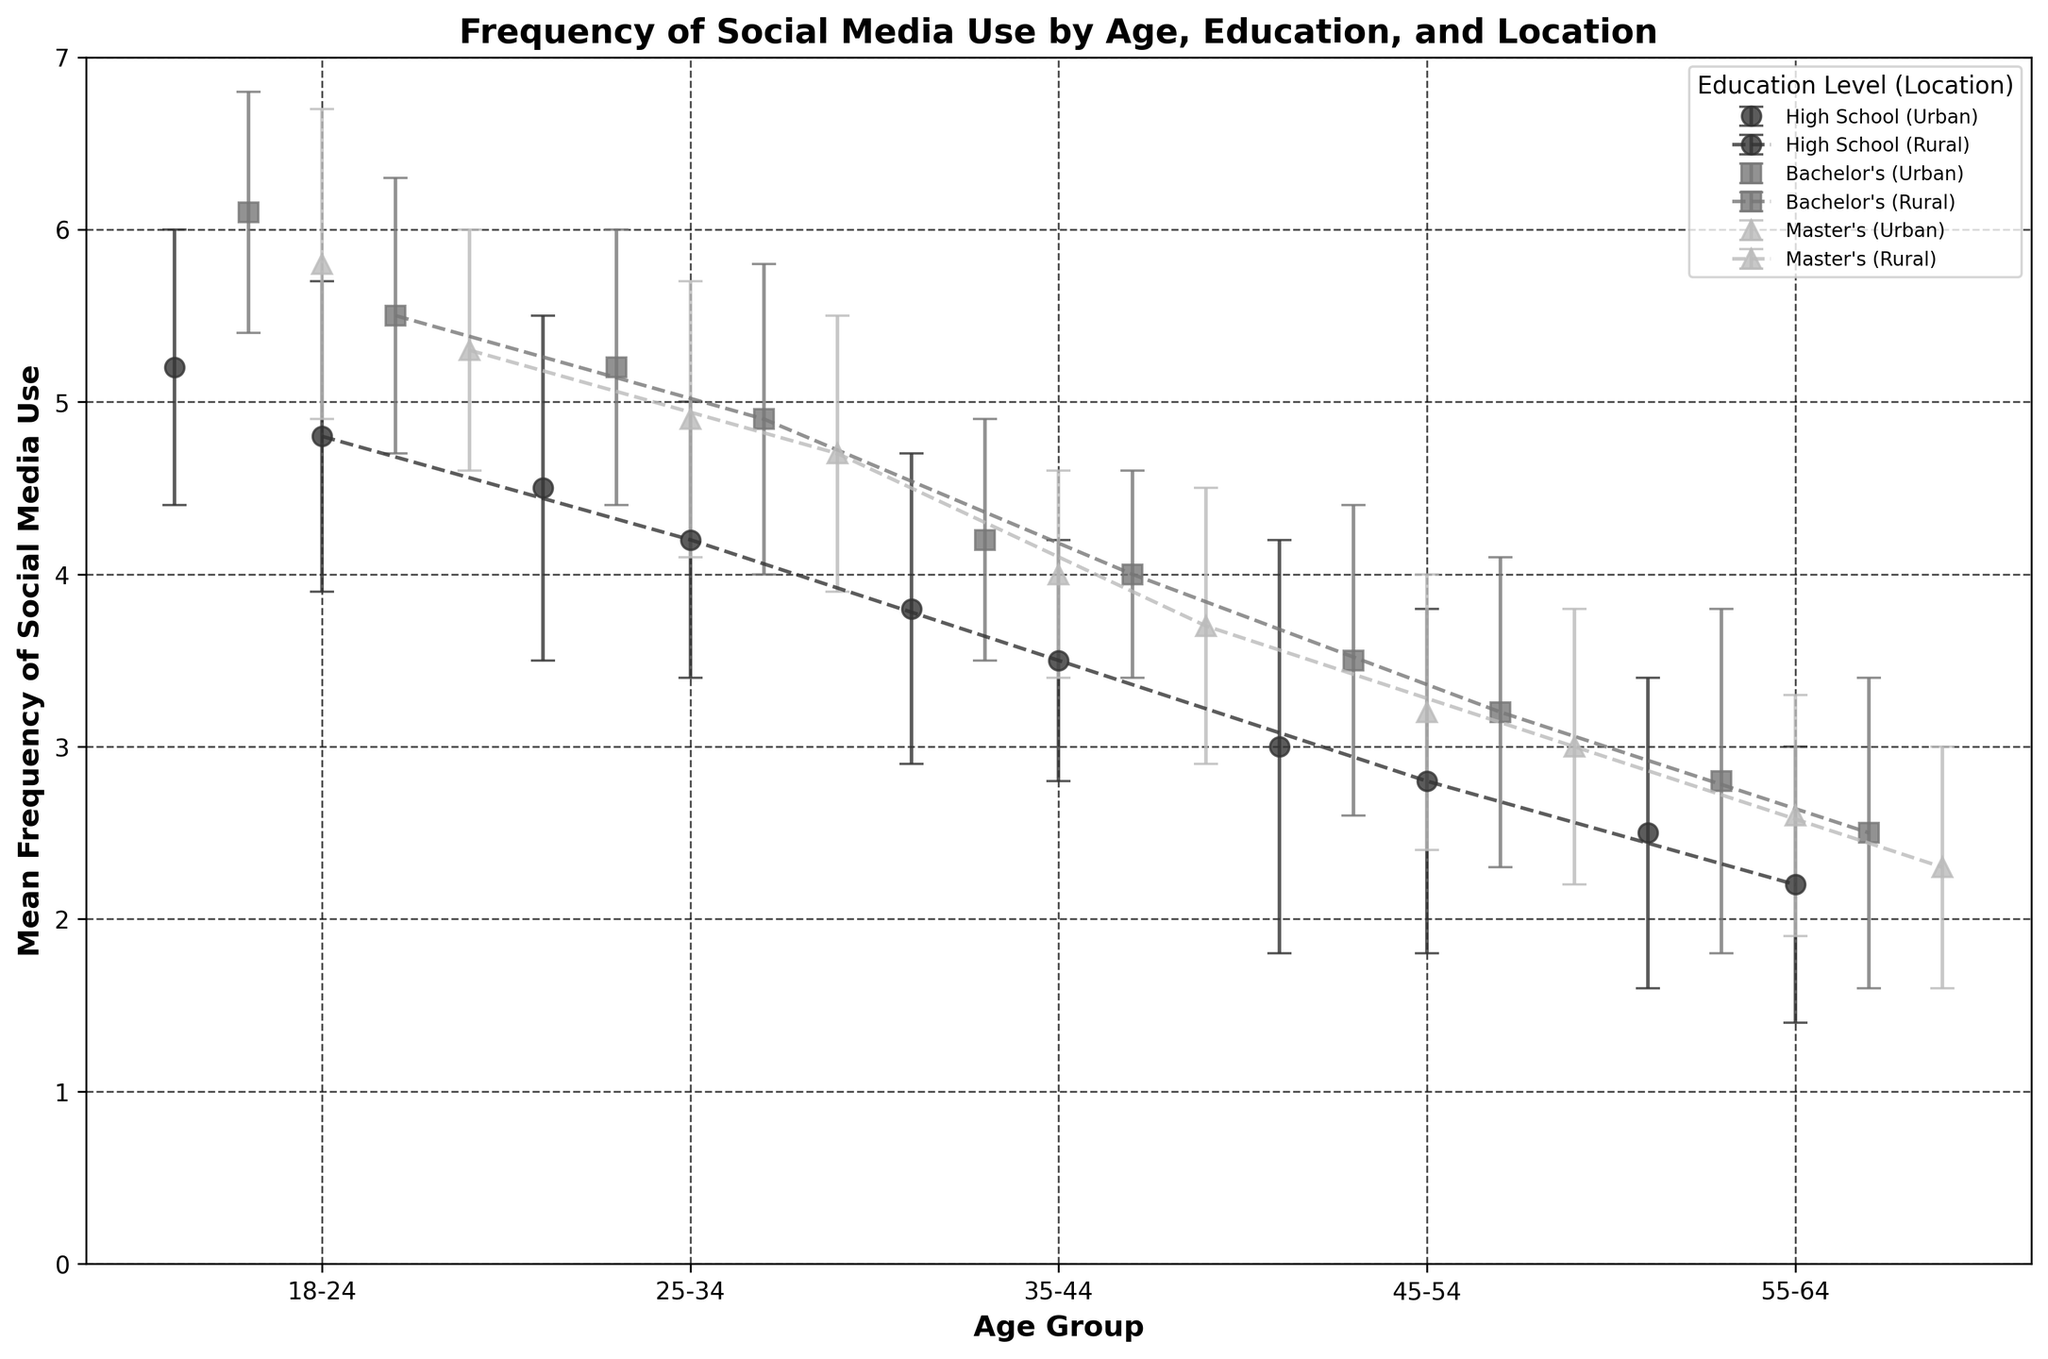What is the title of the figure? The title of the figure is typically located at the top and provides a summary of what the figure represents. In this case, the title of the figure is "Frequency of Social Media Use by Age, Education, and Location".
Answer: Frequency of Social Media Use by Age, Education, and Location Which age group has the highest mean frequency of social media use for individuals with a Bachelor's degree living in urban areas? To determine this, we look at the markers that represent individuals with a Bachelor's degree in urban areas across different age groups. The highest marker implies the highest mean frequency. The 18-24 age group has the highest mean frequency of 6.1.
Answer: 18-24 What is the difference in mean frequency of social media use between the 25-34 and 35-44 age groups for individuals with a Master's degree living in rural areas? We find the mean frequency for 25-34 Master's degree in rural areas (4.7) and for 35-44 (3.7). The difference is calculated as 4.7 - 3.7 = 1.0.
Answer: 1.0 For which education level and geographic location do individuals aged 45-54 have the lowest mean frequency of social media use? By comparing the mean frequency of the 45-54 age group across different education levels and locations, we can see that individuals with a High School education in rural areas have the lowest mean frequency at 2.8.
Answer: High School (Rural) What is the general trend in social media use for individuals with a High School education across different age groups in urban areas? To identify the trend, observe the markers for individuals with a High School education in urban areas across increasing age groups. The mean frequency declines as age increases, starting high in the 18-24 group and decreasing gradually to the 55-64 group.
Answer: Decreasing Which age group has the smallest standard deviation in the mean frequency of social media use for individuals with a Bachelor's degree in rural areas? Standard deviation indicates the spread of the data. By looking at the error bars (representing standard deviation), the 35-44 age group has the smallest error bar at 0.6 among those with a Bachelor's degree in rural areas.
Answer: 35-44 Which geographic location, urban or rural, shows a generally higher mean frequency of social media use? By comparing the markers for urban and rural across age groups and education levels, urban areas consistently have higher mean frequencies indicated by the placement of the markers.
Answer: Urban What is the mean frequency difference between urban and rural locations for individuals aged 18-24 with a Master's degree? Find the mean frequency for the Master's degree 18-24 group in urban (5.8) and rural (5.3). The difference is 5.8 - 5.3 = 0.5.
Answer: 0.5 Which age group has the greatest variability in social media use for individuals with a Bachelor's degree in urban areas? Variability is indicated by the length of error bars. For Bachelor's degree in urban areas, the 45-54 age group has the longest error bar, indicating the greatest variability with a standard deviation of 0.9.
Answer: 45-54 